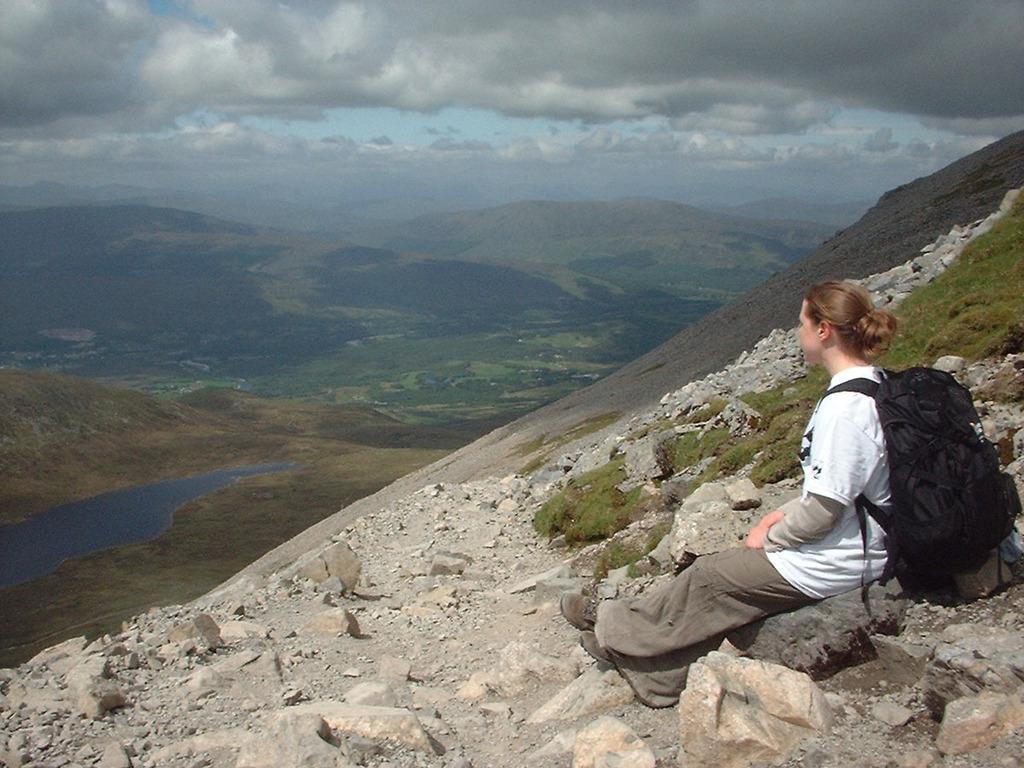Could you give a brief overview of what you see in this image? On the right side of the image we can see a woman, she is seated on the rock and she wore a bag, in the background we can see water, few trees, hills and clouds. 